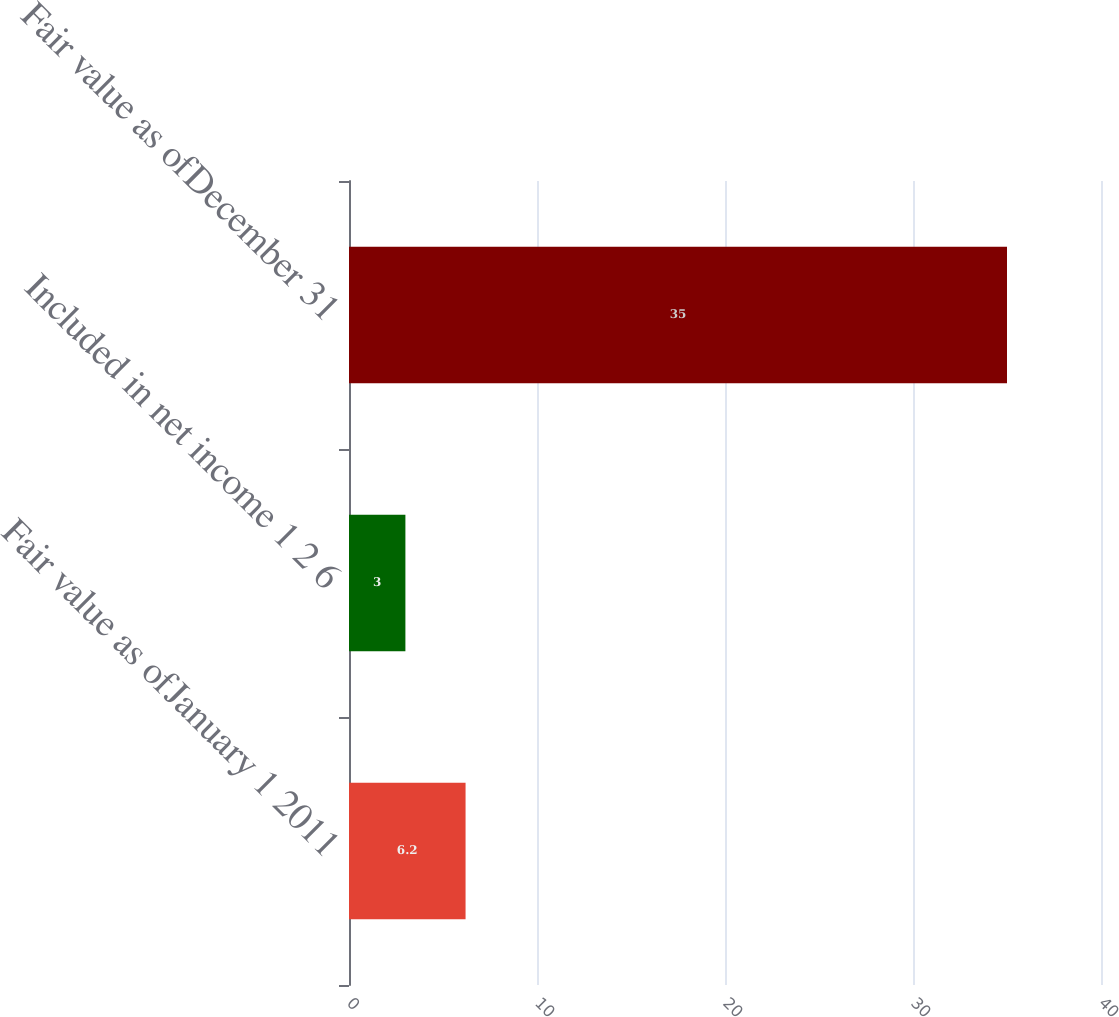Convert chart to OTSL. <chart><loc_0><loc_0><loc_500><loc_500><bar_chart><fcel>Fair value as ofJanuary 1 2011<fcel>Included in net income 1 2 6<fcel>Fair value as ofDecember 31<nl><fcel>6.2<fcel>3<fcel>35<nl></chart> 